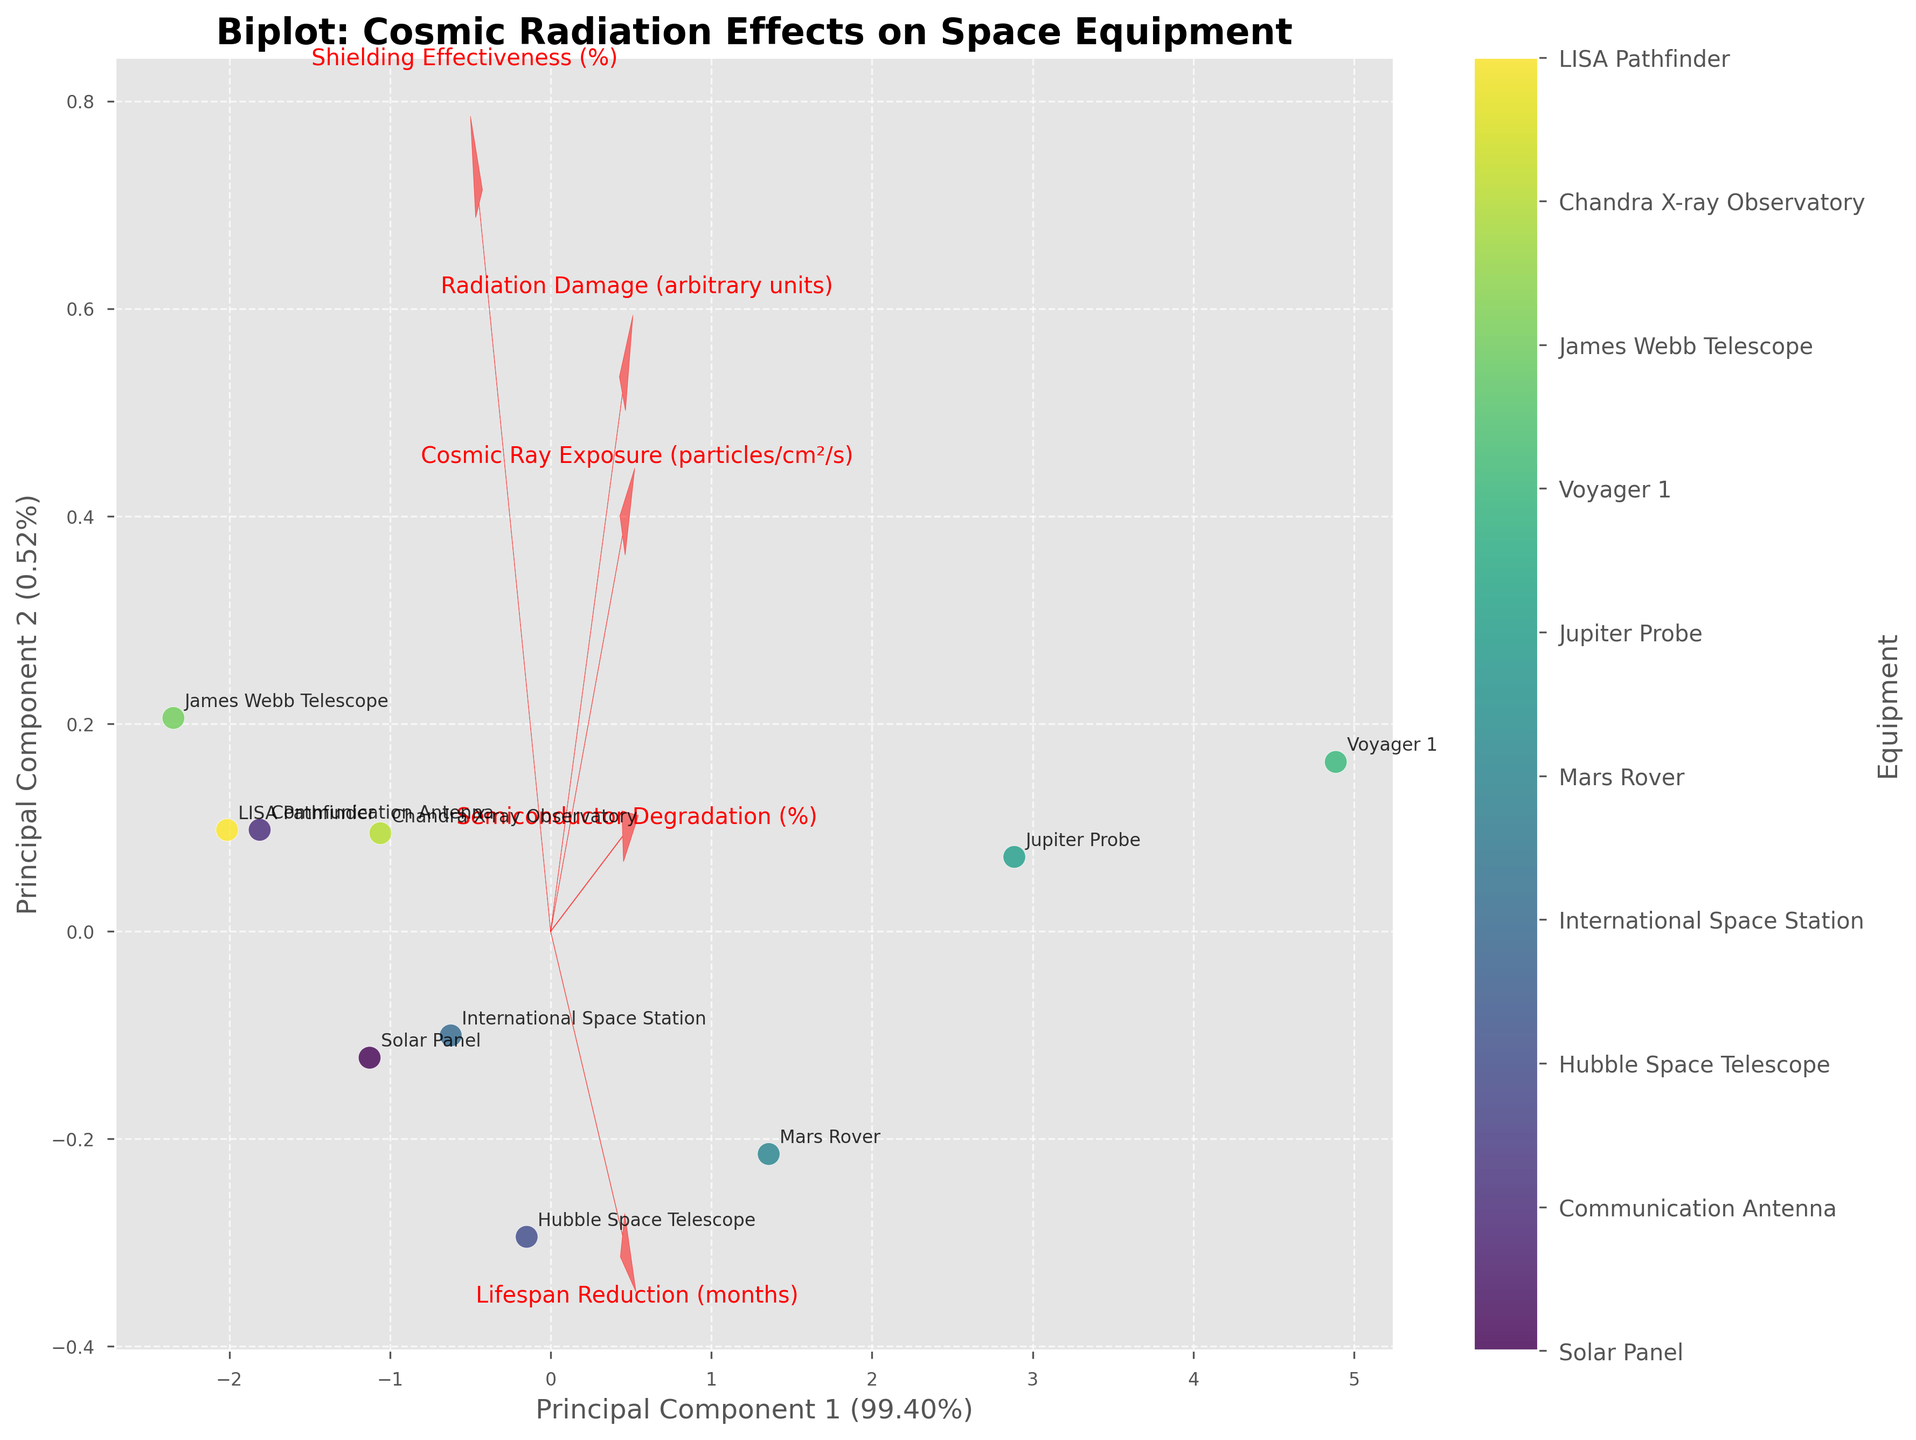Which equipment has the highest value on Principal Component 1? To find the equipment with the highest value on Principal Component 1, look at the x-axis and identify the farthest point to the right. Refer to the annotation to see which equipment it belongs to.
Answer: Voyager 1 What percentage of variation is explained by Principal Component 2? Look at the y-axis label where the percentage of variance explained by Principal Component 2 is mentioned.
Answer: ~24.78% Which two pieces of equipment are closest to each other on the biplot? Identify the points that are nearest to each other on the plot and check their labels.
Answer: Solar Panel and Chandra X-ray Observatory Does the Semiconductor Degradation vector point more towards Principal Component 1 or Principal Component 2? Examine the arrow representing Semiconductor Degradation and see which principal component axis (x or y) it aligns with more closely.
Answer: Principal Component 1 Which piece of equipment has the highest Shielding Effectiveness? Look for the equipment located closer to the end of the arrow labeled Shielding Effectiveness and check its label.
Answer: James Webb Telescope What is the direction of the Lifespan Reduction vector? Observe the arrow labeled with Lifespan Reduction and note its orientation in relation to the origin (0,0).
Answer: Positive for both Principal Components 1 and 2 How does Radiation Damage correlate with Cosmic Ray Exposure? Look at the arrows for Radiation Damage and Cosmic Ray Exposure. If they point in similar directions, they are positively correlated. More divergent arrows indicate less or negative correlation.
Answer: Positively correlated Which equipment has the lowest value on Principal Component 2? To determine the equipment with the lowest value on Principal Component 2, observe the point that is farthest towards the bottom on the y-axis and check its label.
Answer: James Webb Telescope Is there any piece of equipment where the Shielding Effectiveness might limit the impact of cosmic radiation? Look at the direction of the Shielding Effectiveness vector and see if any equipment lies in the opposite direction of vectors related to cosmic radiation impact such as Cosmic Ray Exposure or Radiation Damage.
Answer: James Webb Telescope Which equipment has both high Cosmic Ray Exposure and high Semiconductor Degradation? Locate the points farthest along the directions of the Cosmic Ray Exposure and Semiconductor Degradation arrows. Find if there's an equipment annotated near both these points.
Answer: Voyager 1 